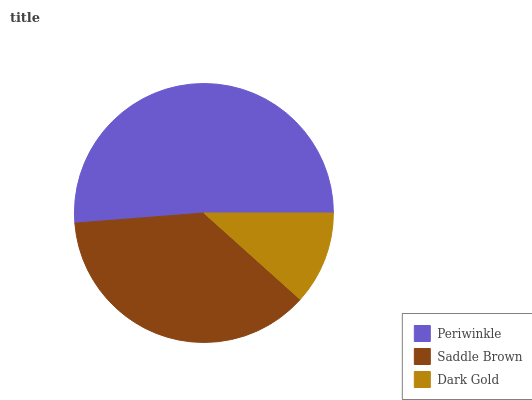Is Dark Gold the minimum?
Answer yes or no. Yes. Is Periwinkle the maximum?
Answer yes or no. Yes. Is Saddle Brown the minimum?
Answer yes or no. No. Is Saddle Brown the maximum?
Answer yes or no. No. Is Periwinkle greater than Saddle Brown?
Answer yes or no. Yes. Is Saddle Brown less than Periwinkle?
Answer yes or no. Yes. Is Saddle Brown greater than Periwinkle?
Answer yes or no. No. Is Periwinkle less than Saddle Brown?
Answer yes or no. No. Is Saddle Brown the high median?
Answer yes or no. Yes. Is Saddle Brown the low median?
Answer yes or no. Yes. Is Periwinkle the high median?
Answer yes or no. No. Is Dark Gold the low median?
Answer yes or no. No. 